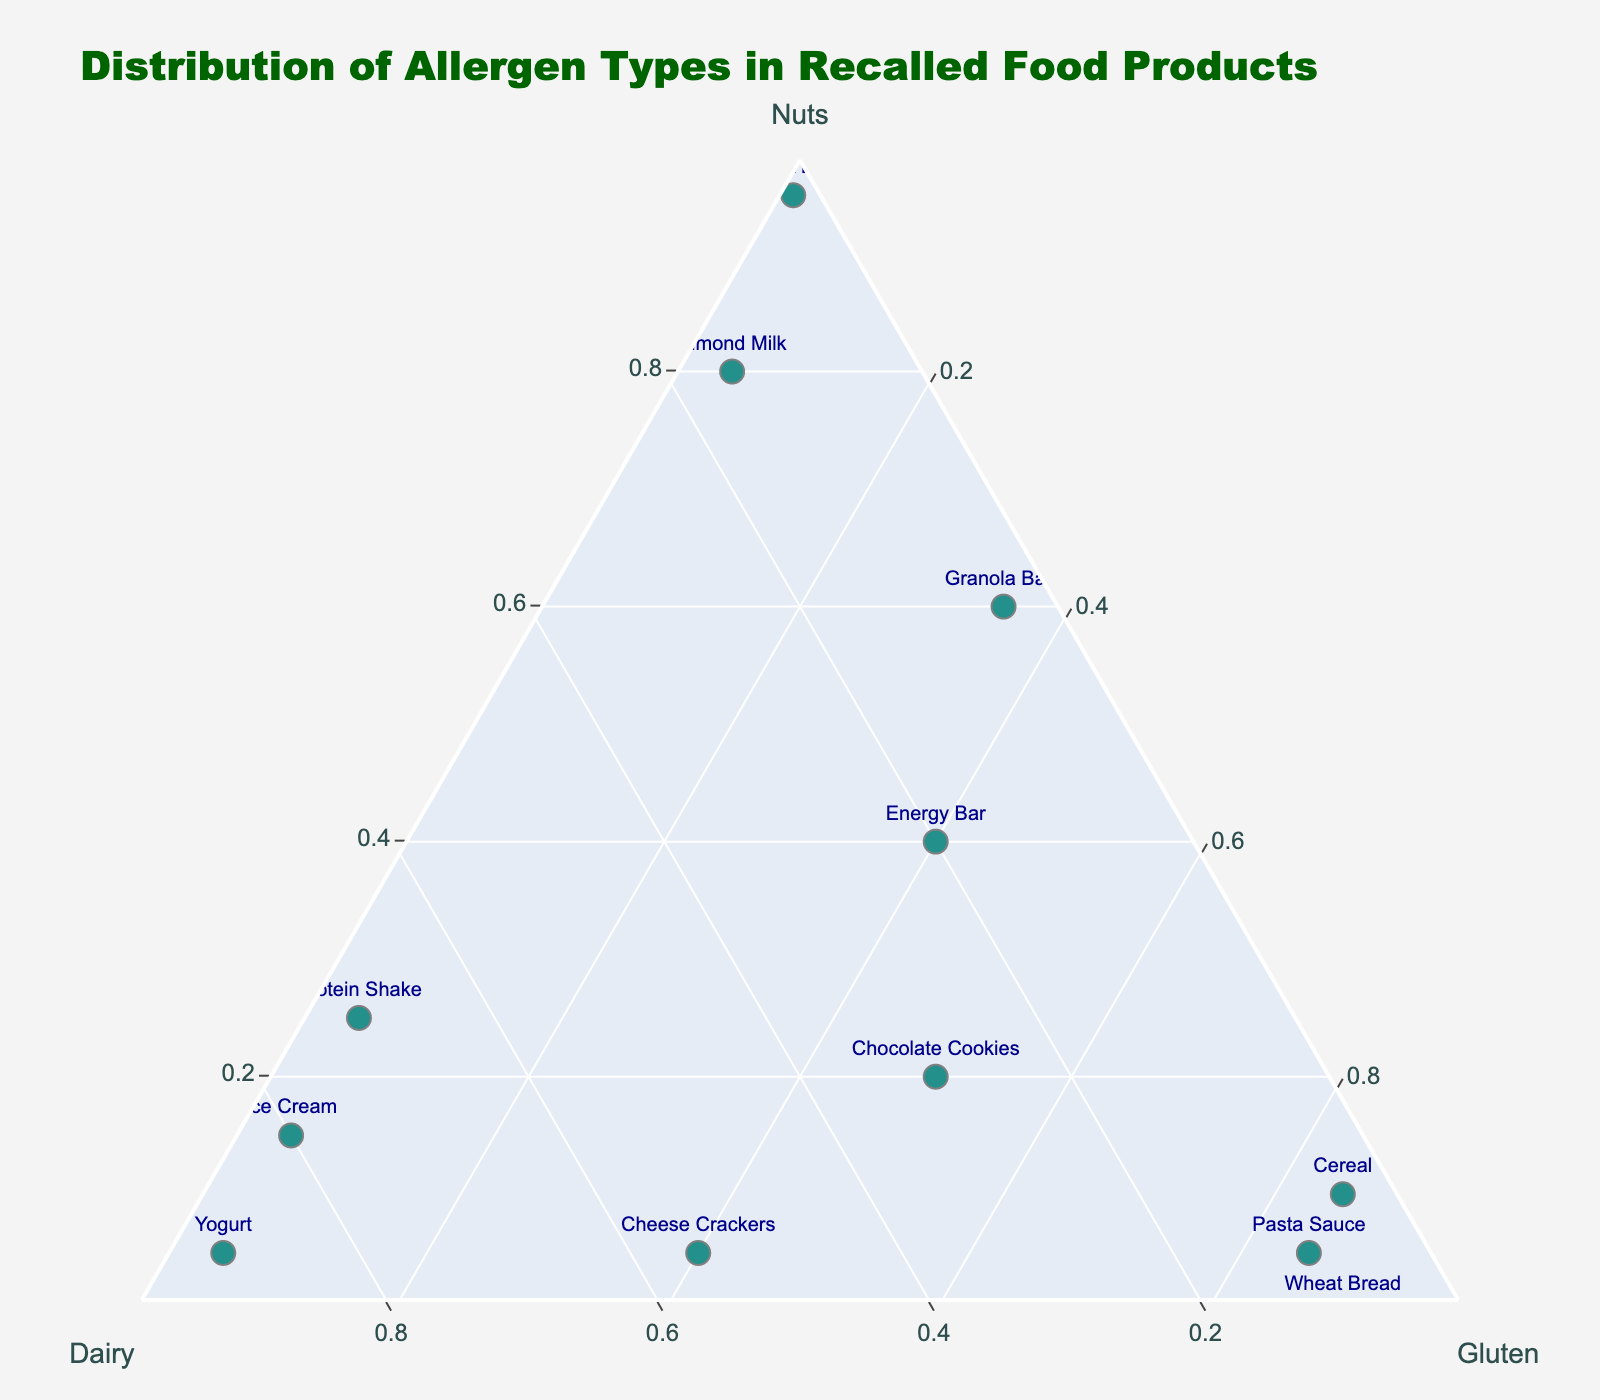How many products are plotted in the Ternary Plot? Count the number of unique products listed in the data and check how many markers appear on the plot.
Answer: 12 What is the title of the figure? The title is typically displayed at the top of the figure; read the text there.
Answer: Distribution of Allergen Types in Recalled Food Products Which product has the highest Nuts allergen content? Check the position close to the 'Nuts' axis, the product with a marker nearest to this apex is the answer.
Answer: Peanut Butter How is the total allergen content represented visually in the plot? Observe the color of the markers. They often represent aggregate measures such as total allergen content.
Answer: Color Scale Among Chocolate Cookies and Energy Bar, which product has a higher Dairy allergen content? Check the relative position on the 'Dairy' axis. The product closer to the 'Dairy' apex has a higher content.
Answer: Chocolate Cookies Which product has an equal distribution of Nuts and Gluten? Look for a marker that is equidistant from the 'Nuts' and 'Gluten' axes.
Answer: Energy Bar Are there any products with zero Nuts content? If so, name them. Check if any marker lies completely on the 'Dairy-Gluten' edge, indicating zero 'Nuts' content.
Answer: Wheat Bread What products have high Dairy allergen content (closest to the Dairy apex)? Identify markers nearest the Dairy end of the ternary plot.
Answer: Yogurt, Protein Shake, Ice Cream On average, do foods with higher Nuts content also have high total allergen content? Examine the color gradients of markers near the Nuts apex and compare their total allergen content visually.
Answer: Yes Which products are in the lower range of total allergen content, based on the color scale? Identify markers with lighter colors, generally near the lower end of the color scale.
Answer: Almond Milk, Peanut Butter 